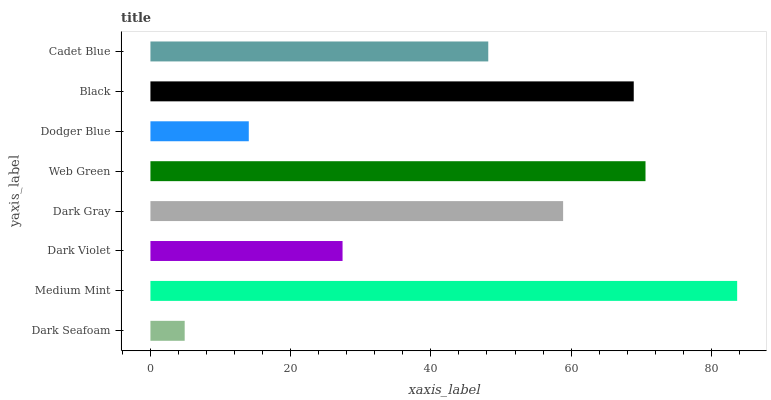Is Dark Seafoam the minimum?
Answer yes or no. Yes. Is Medium Mint the maximum?
Answer yes or no. Yes. Is Dark Violet the minimum?
Answer yes or no. No. Is Dark Violet the maximum?
Answer yes or no. No. Is Medium Mint greater than Dark Violet?
Answer yes or no. Yes. Is Dark Violet less than Medium Mint?
Answer yes or no. Yes. Is Dark Violet greater than Medium Mint?
Answer yes or no. No. Is Medium Mint less than Dark Violet?
Answer yes or no. No. Is Dark Gray the high median?
Answer yes or no. Yes. Is Cadet Blue the low median?
Answer yes or no. Yes. Is Black the high median?
Answer yes or no. No. Is Dodger Blue the low median?
Answer yes or no. No. 